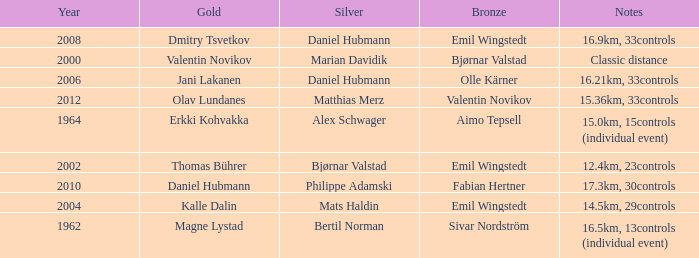WHAT YEAR HAS A SILVER FOR MATTHIAS MERZ? 2012.0. 